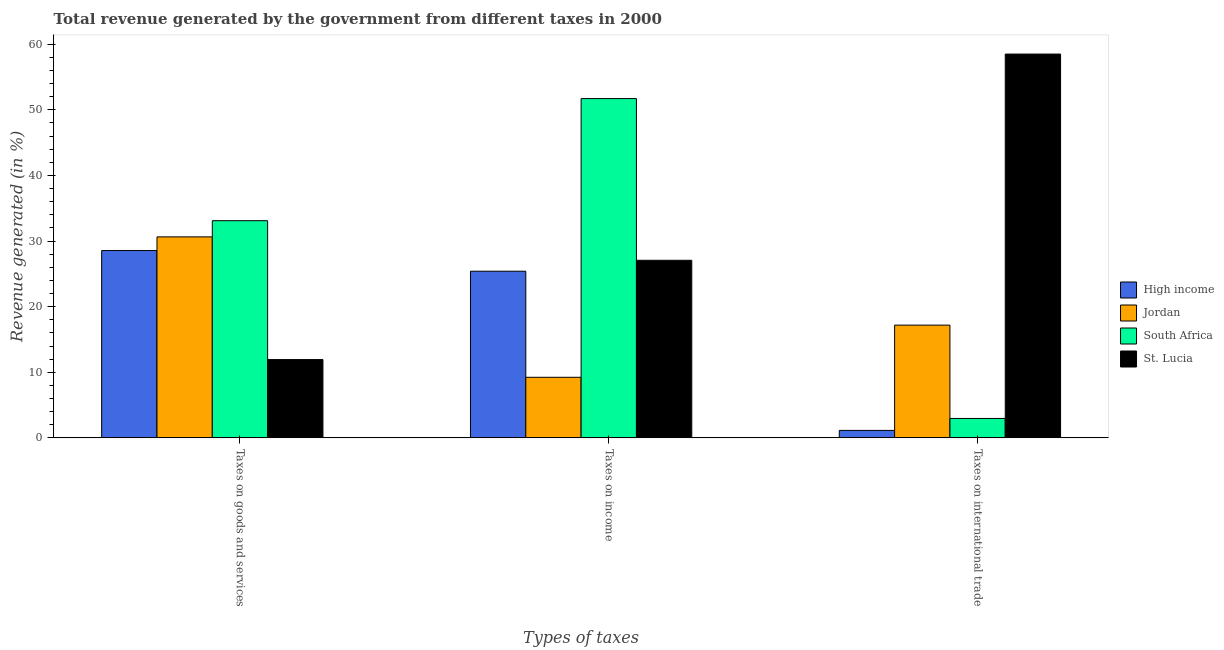How many different coloured bars are there?
Provide a succinct answer. 4. How many bars are there on the 3rd tick from the right?
Provide a succinct answer. 4. What is the label of the 1st group of bars from the left?
Your response must be concise. Taxes on goods and services. What is the percentage of revenue generated by taxes on income in High income?
Your answer should be very brief. 25.4. Across all countries, what is the maximum percentage of revenue generated by taxes on income?
Ensure brevity in your answer.  51.71. Across all countries, what is the minimum percentage of revenue generated by tax on international trade?
Your answer should be very brief. 1.14. In which country was the percentage of revenue generated by tax on international trade maximum?
Provide a short and direct response. St. Lucia. In which country was the percentage of revenue generated by taxes on income minimum?
Provide a succinct answer. Jordan. What is the total percentage of revenue generated by taxes on goods and services in the graph?
Your answer should be very brief. 104.21. What is the difference between the percentage of revenue generated by taxes on income in Jordan and that in St. Lucia?
Keep it short and to the point. -17.83. What is the difference between the percentage of revenue generated by taxes on goods and services in South Africa and the percentage of revenue generated by taxes on income in High income?
Ensure brevity in your answer.  7.7. What is the average percentage of revenue generated by taxes on income per country?
Ensure brevity in your answer.  28.35. What is the difference between the percentage of revenue generated by taxes on income and percentage of revenue generated by tax on international trade in South Africa?
Offer a very short reply. 48.75. In how many countries, is the percentage of revenue generated by tax on international trade greater than 30 %?
Give a very brief answer. 1. What is the ratio of the percentage of revenue generated by tax on international trade in South Africa to that in Jordan?
Make the answer very short. 0.17. What is the difference between the highest and the second highest percentage of revenue generated by taxes on goods and services?
Offer a terse response. 2.47. What is the difference between the highest and the lowest percentage of revenue generated by taxes on goods and services?
Provide a short and direct response. 21.17. In how many countries, is the percentage of revenue generated by tax on international trade greater than the average percentage of revenue generated by tax on international trade taken over all countries?
Keep it short and to the point. 1. What does the 2nd bar from the left in Taxes on income represents?
Provide a short and direct response. Jordan. What does the 1st bar from the right in Taxes on international trade represents?
Your response must be concise. St. Lucia. Are all the bars in the graph horizontal?
Provide a short and direct response. No. Does the graph contain any zero values?
Provide a succinct answer. No. Where does the legend appear in the graph?
Offer a terse response. Center right. How are the legend labels stacked?
Your response must be concise. Vertical. What is the title of the graph?
Ensure brevity in your answer.  Total revenue generated by the government from different taxes in 2000. Does "Serbia" appear as one of the legend labels in the graph?
Your response must be concise. No. What is the label or title of the X-axis?
Offer a very short reply. Types of taxes. What is the label or title of the Y-axis?
Ensure brevity in your answer.  Revenue generated (in %). What is the Revenue generated (in %) in High income in Taxes on goods and services?
Give a very brief answer. 28.55. What is the Revenue generated (in %) in Jordan in Taxes on goods and services?
Give a very brief answer. 30.63. What is the Revenue generated (in %) of South Africa in Taxes on goods and services?
Keep it short and to the point. 33.1. What is the Revenue generated (in %) of St. Lucia in Taxes on goods and services?
Provide a short and direct response. 11.93. What is the Revenue generated (in %) of High income in Taxes on income?
Keep it short and to the point. 25.4. What is the Revenue generated (in %) of Jordan in Taxes on income?
Offer a very short reply. 9.23. What is the Revenue generated (in %) of South Africa in Taxes on income?
Provide a succinct answer. 51.71. What is the Revenue generated (in %) of St. Lucia in Taxes on income?
Offer a very short reply. 27.06. What is the Revenue generated (in %) of High income in Taxes on international trade?
Offer a terse response. 1.14. What is the Revenue generated (in %) in Jordan in Taxes on international trade?
Provide a succinct answer. 17.18. What is the Revenue generated (in %) of South Africa in Taxes on international trade?
Provide a succinct answer. 2.96. What is the Revenue generated (in %) in St. Lucia in Taxes on international trade?
Make the answer very short. 58.49. Across all Types of taxes, what is the maximum Revenue generated (in %) in High income?
Offer a very short reply. 28.55. Across all Types of taxes, what is the maximum Revenue generated (in %) of Jordan?
Provide a succinct answer. 30.63. Across all Types of taxes, what is the maximum Revenue generated (in %) of South Africa?
Keep it short and to the point. 51.71. Across all Types of taxes, what is the maximum Revenue generated (in %) in St. Lucia?
Offer a terse response. 58.49. Across all Types of taxes, what is the minimum Revenue generated (in %) in High income?
Ensure brevity in your answer.  1.14. Across all Types of taxes, what is the minimum Revenue generated (in %) in Jordan?
Keep it short and to the point. 9.23. Across all Types of taxes, what is the minimum Revenue generated (in %) in South Africa?
Give a very brief answer. 2.96. Across all Types of taxes, what is the minimum Revenue generated (in %) in St. Lucia?
Give a very brief answer. 11.93. What is the total Revenue generated (in %) of High income in the graph?
Ensure brevity in your answer.  55.09. What is the total Revenue generated (in %) in Jordan in the graph?
Keep it short and to the point. 57.04. What is the total Revenue generated (in %) in South Africa in the graph?
Make the answer very short. 87.76. What is the total Revenue generated (in %) of St. Lucia in the graph?
Offer a very short reply. 97.48. What is the difference between the Revenue generated (in %) in High income in Taxes on goods and services and that in Taxes on income?
Provide a short and direct response. 3.15. What is the difference between the Revenue generated (in %) of Jordan in Taxes on goods and services and that in Taxes on income?
Your response must be concise. 21.4. What is the difference between the Revenue generated (in %) of South Africa in Taxes on goods and services and that in Taxes on income?
Give a very brief answer. -18.61. What is the difference between the Revenue generated (in %) of St. Lucia in Taxes on goods and services and that in Taxes on income?
Your response must be concise. -15.13. What is the difference between the Revenue generated (in %) in High income in Taxes on goods and services and that in Taxes on international trade?
Ensure brevity in your answer.  27.41. What is the difference between the Revenue generated (in %) of Jordan in Taxes on goods and services and that in Taxes on international trade?
Keep it short and to the point. 13.45. What is the difference between the Revenue generated (in %) in South Africa in Taxes on goods and services and that in Taxes on international trade?
Make the answer very short. 30.14. What is the difference between the Revenue generated (in %) of St. Lucia in Taxes on goods and services and that in Taxes on international trade?
Your response must be concise. -46.56. What is the difference between the Revenue generated (in %) in High income in Taxes on income and that in Taxes on international trade?
Make the answer very short. 24.26. What is the difference between the Revenue generated (in %) in Jordan in Taxes on income and that in Taxes on international trade?
Your response must be concise. -7.95. What is the difference between the Revenue generated (in %) of South Africa in Taxes on income and that in Taxes on international trade?
Offer a terse response. 48.75. What is the difference between the Revenue generated (in %) in St. Lucia in Taxes on income and that in Taxes on international trade?
Offer a very short reply. -31.43. What is the difference between the Revenue generated (in %) in High income in Taxes on goods and services and the Revenue generated (in %) in Jordan in Taxes on income?
Ensure brevity in your answer.  19.32. What is the difference between the Revenue generated (in %) of High income in Taxes on goods and services and the Revenue generated (in %) of South Africa in Taxes on income?
Keep it short and to the point. -23.16. What is the difference between the Revenue generated (in %) in High income in Taxes on goods and services and the Revenue generated (in %) in St. Lucia in Taxes on income?
Your answer should be compact. 1.49. What is the difference between the Revenue generated (in %) in Jordan in Taxes on goods and services and the Revenue generated (in %) in South Africa in Taxes on income?
Offer a very short reply. -21.08. What is the difference between the Revenue generated (in %) in Jordan in Taxes on goods and services and the Revenue generated (in %) in St. Lucia in Taxes on income?
Offer a terse response. 3.57. What is the difference between the Revenue generated (in %) in South Africa in Taxes on goods and services and the Revenue generated (in %) in St. Lucia in Taxes on income?
Offer a very short reply. 6.03. What is the difference between the Revenue generated (in %) in High income in Taxes on goods and services and the Revenue generated (in %) in Jordan in Taxes on international trade?
Offer a very short reply. 11.37. What is the difference between the Revenue generated (in %) of High income in Taxes on goods and services and the Revenue generated (in %) of South Africa in Taxes on international trade?
Give a very brief answer. 25.59. What is the difference between the Revenue generated (in %) in High income in Taxes on goods and services and the Revenue generated (in %) in St. Lucia in Taxes on international trade?
Your answer should be compact. -29.94. What is the difference between the Revenue generated (in %) of Jordan in Taxes on goods and services and the Revenue generated (in %) of South Africa in Taxes on international trade?
Give a very brief answer. 27.67. What is the difference between the Revenue generated (in %) in Jordan in Taxes on goods and services and the Revenue generated (in %) in St. Lucia in Taxes on international trade?
Give a very brief answer. -27.86. What is the difference between the Revenue generated (in %) in South Africa in Taxes on goods and services and the Revenue generated (in %) in St. Lucia in Taxes on international trade?
Make the answer very short. -25.39. What is the difference between the Revenue generated (in %) of High income in Taxes on income and the Revenue generated (in %) of Jordan in Taxes on international trade?
Offer a very short reply. 8.22. What is the difference between the Revenue generated (in %) of High income in Taxes on income and the Revenue generated (in %) of South Africa in Taxes on international trade?
Your response must be concise. 22.44. What is the difference between the Revenue generated (in %) of High income in Taxes on income and the Revenue generated (in %) of St. Lucia in Taxes on international trade?
Provide a succinct answer. -33.09. What is the difference between the Revenue generated (in %) of Jordan in Taxes on income and the Revenue generated (in %) of South Africa in Taxes on international trade?
Offer a very short reply. 6.27. What is the difference between the Revenue generated (in %) in Jordan in Taxes on income and the Revenue generated (in %) in St. Lucia in Taxes on international trade?
Your answer should be compact. -49.26. What is the difference between the Revenue generated (in %) in South Africa in Taxes on income and the Revenue generated (in %) in St. Lucia in Taxes on international trade?
Offer a very short reply. -6.78. What is the average Revenue generated (in %) of High income per Types of taxes?
Give a very brief answer. 18.36. What is the average Revenue generated (in %) of Jordan per Types of taxes?
Ensure brevity in your answer.  19.01. What is the average Revenue generated (in %) in South Africa per Types of taxes?
Your answer should be compact. 29.25. What is the average Revenue generated (in %) of St. Lucia per Types of taxes?
Give a very brief answer. 32.49. What is the difference between the Revenue generated (in %) in High income and Revenue generated (in %) in Jordan in Taxes on goods and services?
Give a very brief answer. -2.08. What is the difference between the Revenue generated (in %) in High income and Revenue generated (in %) in South Africa in Taxes on goods and services?
Your response must be concise. -4.55. What is the difference between the Revenue generated (in %) in High income and Revenue generated (in %) in St. Lucia in Taxes on goods and services?
Your answer should be compact. 16.62. What is the difference between the Revenue generated (in %) in Jordan and Revenue generated (in %) in South Africa in Taxes on goods and services?
Offer a very short reply. -2.47. What is the difference between the Revenue generated (in %) of Jordan and Revenue generated (in %) of St. Lucia in Taxes on goods and services?
Give a very brief answer. 18.7. What is the difference between the Revenue generated (in %) of South Africa and Revenue generated (in %) of St. Lucia in Taxes on goods and services?
Make the answer very short. 21.17. What is the difference between the Revenue generated (in %) in High income and Revenue generated (in %) in Jordan in Taxes on income?
Ensure brevity in your answer.  16.17. What is the difference between the Revenue generated (in %) in High income and Revenue generated (in %) in South Africa in Taxes on income?
Make the answer very short. -26.31. What is the difference between the Revenue generated (in %) of High income and Revenue generated (in %) of St. Lucia in Taxes on income?
Provide a succinct answer. -1.66. What is the difference between the Revenue generated (in %) of Jordan and Revenue generated (in %) of South Africa in Taxes on income?
Ensure brevity in your answer.  -42.47. What is the difference between the Revenue generated (in %) in Jordan and Revenue generated (in %) in St. Lucia in Taxes on income?
Provide a succinct answer. -17.83. What is the difference between the Revenue generated (in %) in South Africa and Revenue generated (in %) in St. Lucia in Taxes on income?
Give a very brief answer. 24.64. What is the difference between the Revenue generated (in %) in High income and Revenue generated (in %) in Jordan in Taxes on international trade?
Your answer should be very brief. -16.04. What is the difference between the Revenue generated (in %) in High income and Revenue generated (in %) in South Africa in Taxes on international trade?
Your answer should be very brief. -1.82. What is the difference between the Revenue generated (in %) of High income and Revenue generated (in %) of St. Lucia in Taxes on international trade?
Your answer should be compact. -57.35. What is the difference between the Revenue generated (in %) in Jordan and Revenue generated (in %) in South Africa in Taxes on international trade?
Ensure brevity in your answer.  14.22. What is the difference between the Revenue generated (in %) of Jordan and Revenue generated (in %) of St. Lucia in Taxes on international trade?
Offer a very short reply. -41.31. What is the difference between the Revenue generated (in %) in South Africa and Revenue generated (in %) in St. Lucia in Taxes on international trade?
Give a very brief answer. -55.53. What is the ratio of the Revenue generated (in %) in High income in Taxes on goods and services to that in Taxes on income?
Make the answer very short. 1.12. What is the ratio of the Revenue generated (in %) of Jordan in Taxes on goods and services to that in Taxes on income?
Ensure brevity in your answer.  3.32. What is the ratio of the Revenue generated (in %) in South Africa in Taxes on goods and services to that in Taxes on income?
Keep it short and to the point. 0.64. What is the ratio of the Revenue generated (in %) in St. Lucia in Taxes on goods and services to that in Taxes on income?
Make the answer very short. 0.44. What is the ratio of the Revenue generated (in %) in High income in Taxes on goods and services to that in Taxes on international trade?
Give a very brief answer. 25.05. What is the ratio of the Revenue generated (in %) in Jordan in Taxes on goods and services to that in Taxes on international trade?
Ensure brevity in your answer.  1.78. What is the ratio of the Revenue generated (in %) of South Africa in Taxes on goods and services to that in Taxes on international trade?
Offer a terse response. 11.19. What is the ratio of the Revenue generated (in %) in St. Lucia in Taxes on goods and services to that in Taxes on international trade?
Your response must be concise. 0.2. What is the ratio of the Revenue generated (in %) of High income in Taxes on income to that in Taxes on international trade?
Give a very brief answer. 22.29. What is the ratio of the Revenue generated (in %) of Jordan in Taxes on income to that in Taxes on international trade?
Give a very brief answer. 0.54. What is the ratio of the Revenue generated (in %) of South Africa in Taxes on income to that in Taxes on international trade?
Your answer should be very brief. 17.48. What is the ratio of the Revenue generated (in %) of St. Lucia in Taxes on income to that in Taxes on international trade?
Offer a terse response. 0.46. What is the difference between the highest and the second highest Revenue generated (in %) in High income?
Provide a short and direct response. 3.15. What is the difference between the highest and the second highest Revenue generated (in %) in Jordan?
Make the answer very short. 13.45. What is the difference between the highest and the second highest Revenue generated (in %) in South Africa?
Keep it short and to the point. 18.61. What is the difference between the highest and the second highest Revenue generated (in %) in St. Lucia?
Your answer should be compact. 31.43. What is the difference between the highest and the lowest Revenue generated (in %) in High income?
Offer a very short reply. 27.41. What is the difference between the highest and the lowest Revenue generated (in %) of Jordan?
Your answer should be compact. 21.4. What is the difference between the highest and the lowest Revenue generated (in %) of South Africa?
Your answer should be very brief. 48.75. What is the difference between the highest and the lowest Revenue generated (in %) in St. Lucia?
Make the answer very short. 46.56. 